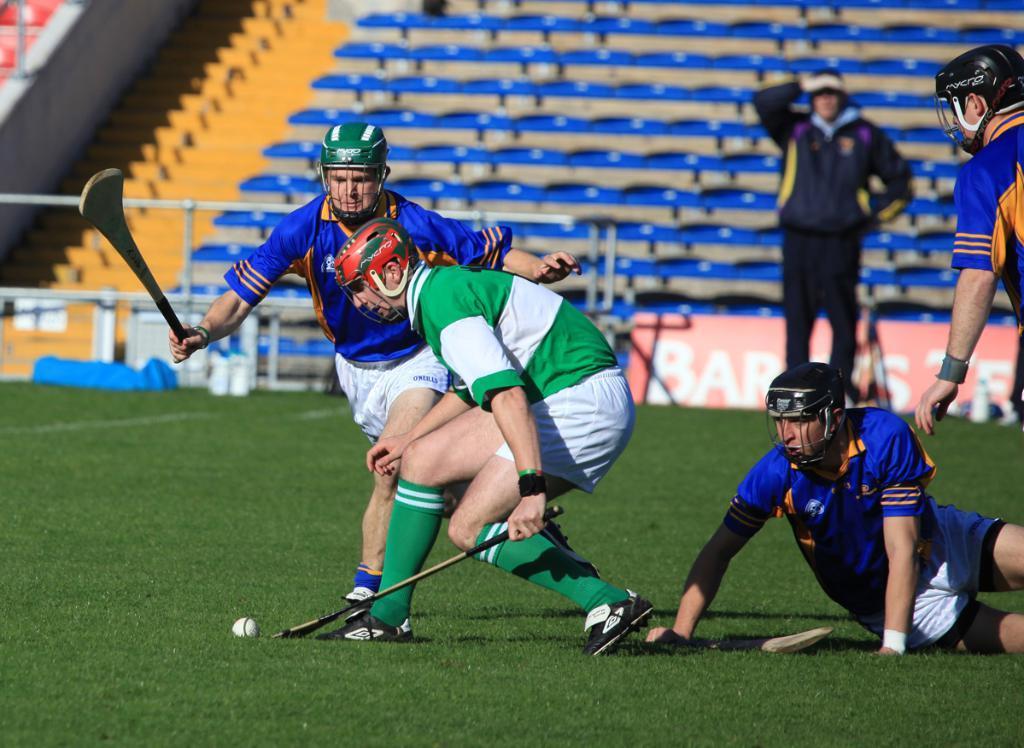In one or two sentences, can you explain what this image depicts? In this picture, we see two men are holding the sticks. In front of them, we see a ball. Behind them, we see a man on the ground. They might be playing the game. The man on the right side is standing. At the bottom, we see the grass. Behind them, we see a man is standing. Behind him, we see a board in pink color with some text written on it. Beside that, we see the railing. In the background, we see the empty chairs. This picture might be clicked in the stadium. 